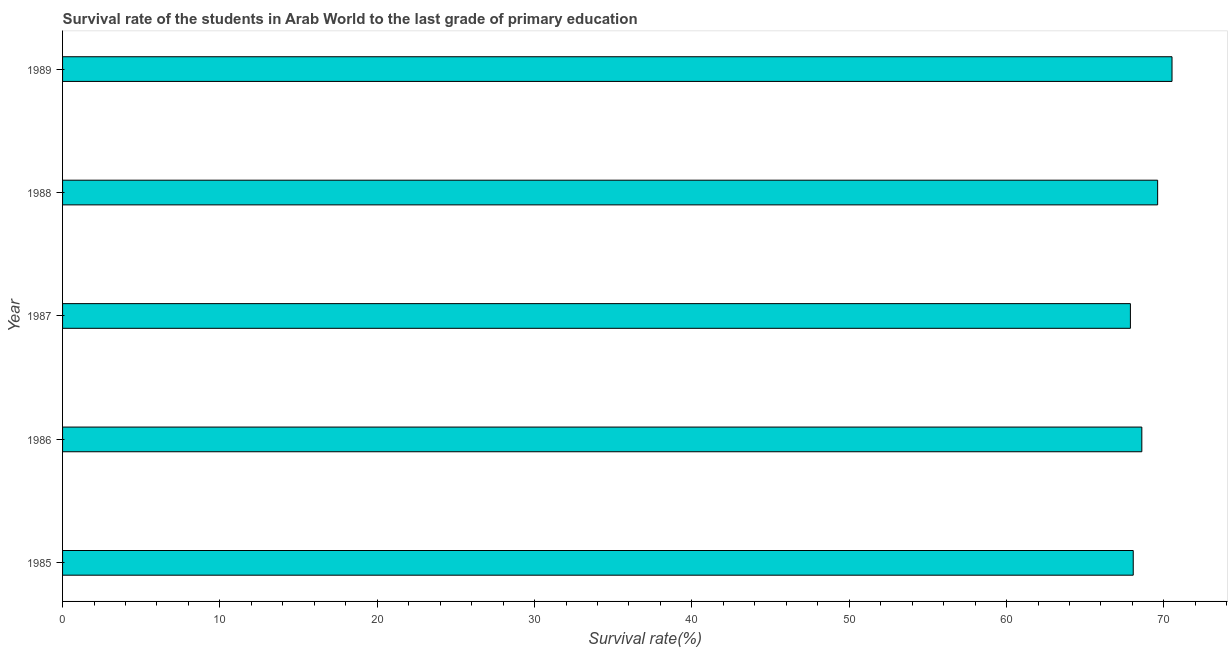Does the graph contain grids?
Your answer should be compact. No. What is the title of the graph?
Keep it short and to the point. Survival rate of the students in Arab World to the last grade of primary education. What is the label or title of the X-axis?
Provide a short and direct response. Survival rate(%). What is the survival rate in primary education in 1986?
Provide a succinct answer. 68.6. Across all years, what is the maximum survival rate in primary education?
Your answer should be very brief. 70.52. Across all years, what is the minimum survival rate in primary education?
Your response must be concise. 67.87. In which year was the survival rate in primary education minimum?
Ensure brevity in your answer.  1987. What is the sum of the survival rate in primary education?
Offer a very short reply. 344.63. What is the difference between the survival rate in primary education in 1986 and 1988?
Make the answer very short. -1. What is the average survival rate in primary education per year?
Keep it short and to the point. 68.93. What is the median survival rate in primary education?
Provide a short and direct response. 68.6. Is the survival rate in primary education in 1986 less than that in 1987?
Ensure brevity in your answer.  No. What is the difference between the highest and the second highest survival rate in primary education?
Offer a very short reply. 0.91. What is the difference between the highest and the lowest survival rate in primary education?
Keep it short and to the point. 2.64. What is the Survival rate(%) in 1985?
Make the answer very short. 68.05. What is the Survival rate(%) of 1986?
Offer a terse response. 68.6. What is the Survival rate(%) in 1987?
Your answer should be very brief. 67.87. What is the Survival rate(%) of 1988?
Your answer should be compact. 69.6. What is the Survival rate(%) in 1989?
Keep it short and to the point. 70.52. What is the difference between the Survival rate(%) in 1985 and 1986?
Your response must be concise. -0.55. What is the difference between the Survival rate(%) in 1985 and 1987?
Give a very brief answer. 0.18. What is the difference between the Survival rate(%) in 1985 and 1988?
Your response must be concise. -1.55. What is the difference between the Survival rate(%) in 1985 and 1989?
Give a very brief answer. -2.47. What is the difference between the Survival rate(%) in 1986 and 1987?
Your response must be concise. 0.73. What is the difference between the Survival rate(%) in 1986 and 1988?
Ensure brevity in your answer.  -1. What is the difference between the Survival rate(%) in 1986 and 1989?
Offer a terse response. -1.92. What is the difference between the Survival rate(%) in 1987 and 1988?
Your response must be concise. -1.73. What is the difference between the Survival rate(%) in 1987 and 1989?
Offer a very short reply. -2.64. What is the difference between the Survival rate(%) in 1988 and 1989?
Provide a succinct answer. -0.91. What is the ratio of the Survival rate(%) in 1985 to that in 1986?
Ensure brevity in your answer.  0.99. What is the ratio of the Survival rate(%) in 1985 to that in 1988?
Your response must be concise. 0.98. What is the ratio of the Survival rate(%) in 1986 to that in 1989?
Your response must be concise. 0.97. What is the ratio of the Survival rate(%) in 1987 to that in 1988?
Provide a succinct answer. 0.97. 